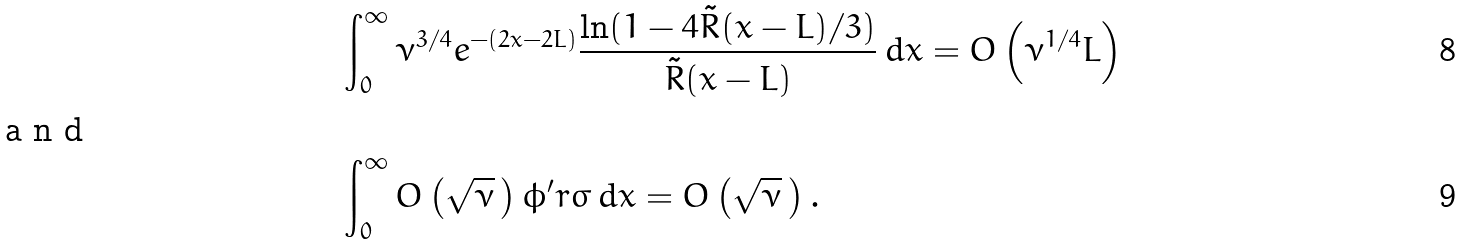<formula> <loc_0><loc_0><loc_500><loc_500>& \int _ { 0 } ^ { \infty } \nu ^ { 3 / 4 } e ^ { - ( 2 x - 2 L ) } \frac { \ln ( 1 - 4 \tilde { R } ( x - L ) / 3 ) } { \tilde { R } ( x - L ) } \, d x = O \left ( \nu ^ { 1 / 4 } L \right ) \\ \intertext { a n d } & \int _ { 0 } ^ { \infty } O \left ( \sqrt { \nu } \, \right ) \phi ^ { \prime } r \sigma \, d x = O \left ( \sqrt { \nu } \, \right ) .</formula> 